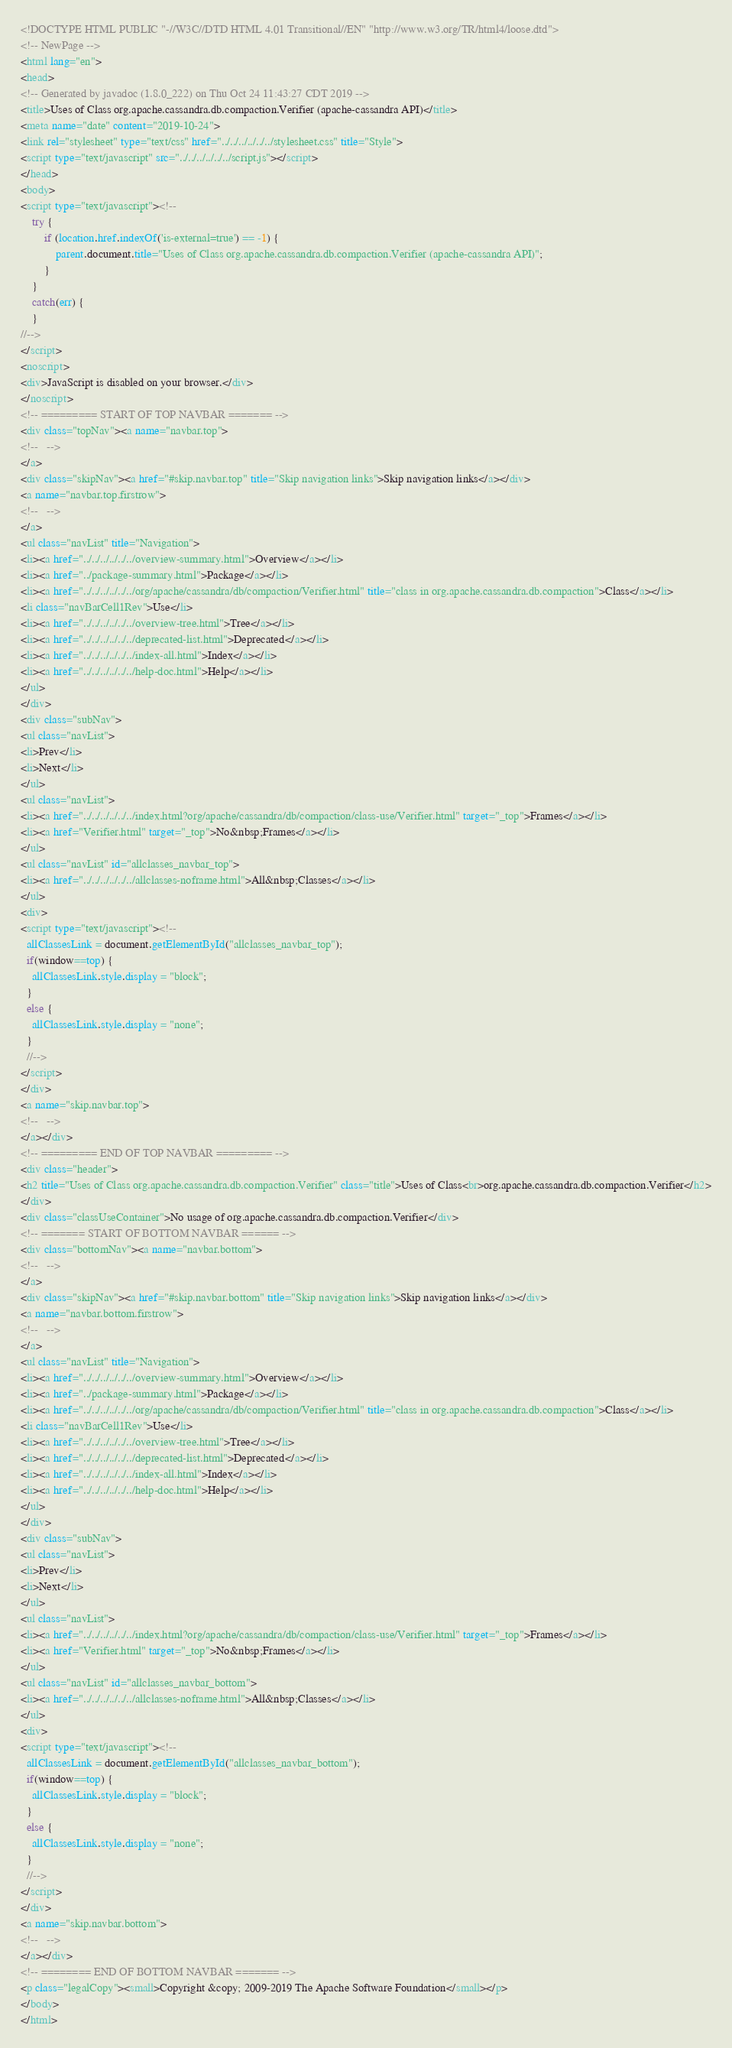Convert code to text. <code><loc_0><loc_0><loc_500><loc_500><_HTML_><!DOCTYPE HTML PUBLIC "-//W3C//DTD HTML 4.01 Transitional//EN" "http://www.w3.org/TR/html4/loose.dtd">
<!-- NewPage -->
<html lang="en">
<head>
<!-- Generated by javadoc (1.8.0_222) on Thu Oct 24 11:43:27 CDT 2019 -->
<title>Uses of Class org.apache.cassandra.db.compaction.Verifier (apache-cassandra API)</title>
<meta name="date" content="2019-10-24">
<link rel="stylesheet" type="text/css" href="../../../../../../stylesheet.css" title="Style">
<script type="text/javascript" src="../../../../../../script.js"></script>
</head>
<body>
<script type="text/javascript"><!--
    try {
        if (location.href.indexOf('is-external=true') == -1) {
            parent.document.title="Uses of Class org.apache.cassandra.db.compaction.Verifier (apache-cassandra API)";
        }
    }
    catch(err) {
    }
//-->
</script>
<noscript>
<div>JavaScript is disabled on your browser.</div>
</noscript>
<!-- ========= START OF TOP NAVBAR ======= -->
<div class="topNav"><a name="navbar.top">
<!--   -->
</a>
<div class="skipNav"><a href="#skip.navbar.top" title="Skip navigation links">Skip navigation links</a></div>
<a name="navbar.top.firstrow">
<!--   -->
</a>
<ul class="navList" title="Navigation">
<li><a href="../../../../../../overview-summary.html">Overview</a></li>
<li><a href="../package-summary.html">Package</a></li>
<li><a href="../../../../../../org/apache/cassandra/db/compaction/Verifier.html" title="class in org.apache.cassandra.db.compaction">Class</a></li>
<li class="navBarCell1Rev">Use</li>
<li><a href="../../../../../../overview-tree.html">Tree</a></li>
<li><a href="../../../../../../deprecated-list.html">Deprecated</a></li>
<li><a href="../../../../../../index-all.html">Index</a></li>
<li><a href="../../../../../../help-doc.html">Help</a></li>
</ul>
</div>
<div class="subNav">
<ul class="navList">
<li>Prev</li>
<li>Next</li>
</ul>
<ul class="navList">
<li><a href="../../../../../../index.html?org/apache/cassandra/db/compaction/class-use/Verifier.html" target="_top">Frames</a></li>
<li><a href="Verifier.html" target="_top">No&nbsp;Frames</a></li>
</ul>
<ul class="navList" id="allclasses_navbar_top">
<li><a href="../../../../../../allclasses-noframe.html">All&nbsp;Classes</a></li>
</ul>
<div>
<script type="text/javascript"><!--
  allClassesLink = document.getElementById("allclasses_navbar_top");
  if(window==top) {
    allClassesLink.style.display = "block";
  }
  else {
    allClassesLink.style.display = "none";
  }
  //-->
</script>
</div>
<a name="skip.navbar.top">
<!--   -->
</a></div>
<!-- ========= END OF TOP NAVBAR ========= -->
<div class="header">
<h2 title="Uses of Class org.apache.cassandra.db.compaction.Verifier" class="title">Uses of Class<br>org.apache.cassandra.db.compaction.Verifier</h2>
</div>
<div class="classUseContainer">No usage of org.apache.cassandra.db.compaction.Verifier</div>
<!-- ======= START OF BOTTOM NAVBAR ====== -->
<div class="bottomNav"><a name="navbar.bottom">
<!--   -->
</a>
<div class="skipNav"><a href="#skip.navbar.bottom" title="Skip navigation links">Skip navigation links</a></div>
<a name="navbar.bottom.firstrow">
<!--   -->
</a>
<ul class="navList" title="Navigation">
<li><a href="../../../../../../overview-summary.html">Overview</a></li>
<li><a href="../package-summary.html">Package</a></li>
<li><a href="../../../../../../org/apache/cassandra/db/compaction/Verifier.html" title="class in org.apache.cassandra.db.compaction">Class</a></li>
<li class="navBarCell1Rev">Use</li>
<li><a href="../../../../../../overview-tree.html">Tree</a></li>
<li><a href="../../../../../../deprecated-list.html">Deprecated</a></li>
<li><a href="../../../../../../index-all.html">Index</a></li>
<li><a href="../../../../../../help-doc.html">Help</a></li>
</ul>
</div>
<div class="subNav">
<ul class="navList">
<li>Prev</li>
<li>Next</li>
</ul>
<ul class="navList">
<li><a href="../../../../../../index.html?org/apache/cassandra/db/compaction/class-use/Verifier.html" target="_top">Frames</a></li>
<li><a href="Verifier.html" target="_top">No&nbsp;Frames</a></li>
</ul>
<ul class="navList" id="allclasses_navbar_bottom">
<li><a href="../../../../../../allclasses-noframe.html">All&nbsp;Classes</a></li>
</ul>
<div>
<script type="text/javascript"><!--
  allClassesLink = document.getElementById("allclasses_navbar_bottom");
  if(window==top) {
    allClassesLink.style.display = "block";
  }
  else {
    allClassesLink.style.display = "none";
  }
  //-->
</script>
</div>
<a name="skip.navbar.bottom">
<!--   -->
</a></div>
<!-- ======== END OF BOTTOM NAVBAR ======= -->
<p class="legalCopy"><small>Copyright &copy; 2009-2019 The Apache Software Foundation</small></p>
</body>
</html>
</code> 